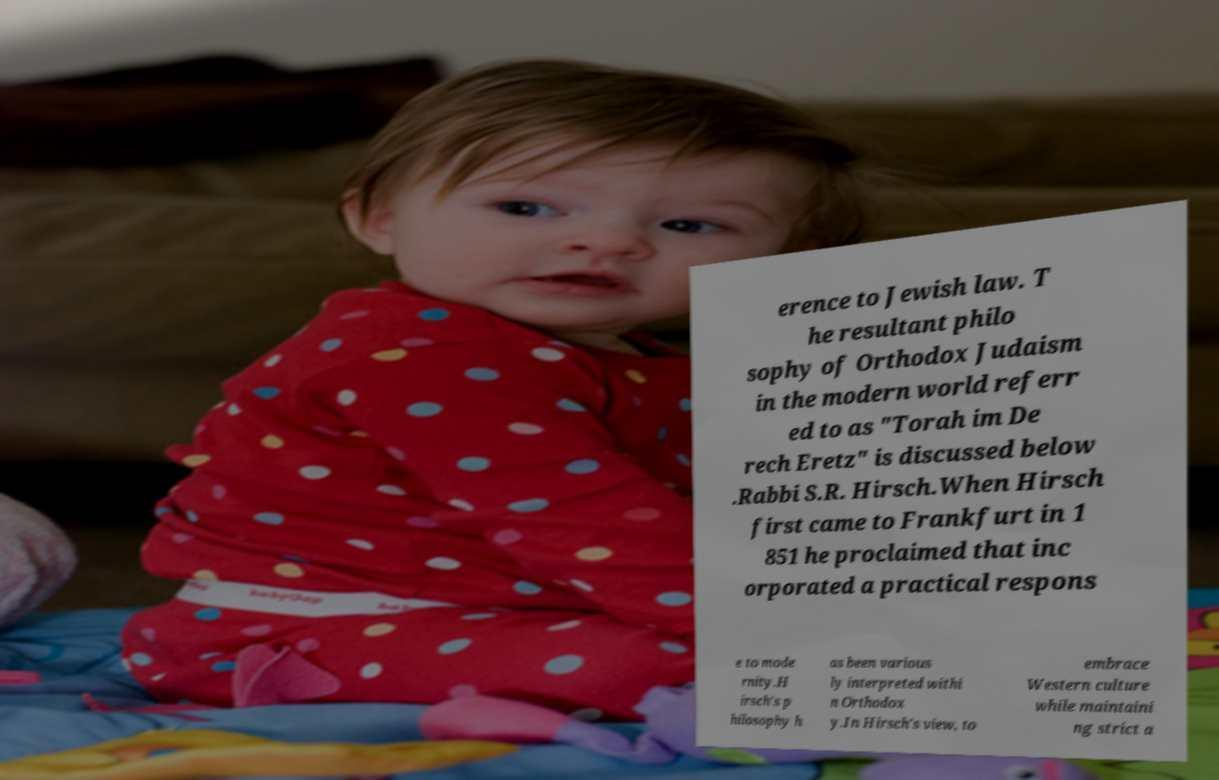There's text embedded in this image that I need extracted. Can you transcribe it verbatim? erence to Jewish law. T he resultant philo sophy of Orthodox Judaism in the modern world referr ed to as "Torah im De rech Eretz" is discussed below .Rabbi S.R. Hirsch.When Hirsch first came to Frankfurt in 1 851 he proclaimed that inc orporated a practical respons e to mode rnity.H irsch's p hilosophy h as been various ly interpreted withi n Orthodox y.In Hirsch's view, to embrace Western culture while maintaini ng strict a 